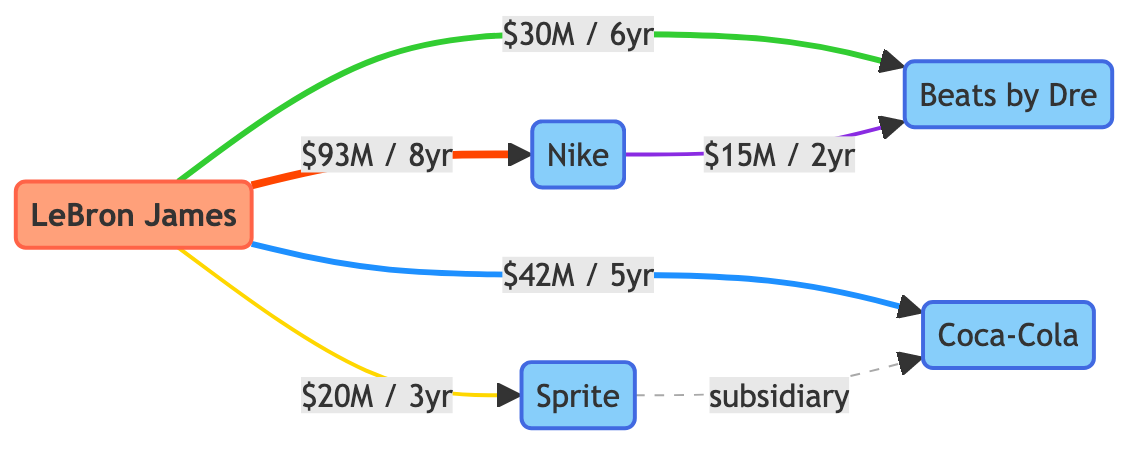What is the duration of LeBron James' endorsement deal with Nike? The diagram highlights the endorsement link between LeBron James and Nike, which specifies a duration of 8 years.
Answer: 8 years What is the deal value for LeBron James' partnership with Coca-Cola? The diagram shows a direct endorsement connection between LeBron James and Coca-Cola with a deal value of 42 million USD.
Answer: 42 million USD How many brands are connected to LeBron James in the diagram? By reviewing the connections from LeBron James, we see he has endorsements with four different brands: Nike, Coca-Cola, Beats, and Sprite, totaling four brands.
Answer: 4 What type of relationship exists between Sprite and Coca-Cola? The diagram illustrates a dashed relationship labeled as "subsidiary" between Sprite and Coca-Cola, indicating a specific business relationship.
Answer: subsidiary What is the total deal value of the endorsement contracts that LeBron James has? To find the total, I add the individual deal values: 93 million (Nike) + 42 million (Coca-Cola) + 30 million (Beats) + 20 million (Sprite), resulting in a total of 185 million USD.
Answer: 185 million USD Which brand has the largest market capitalization? The diagram presents market capitalizations for all brands: Nike (241 billion USD), Coca-Cola (252 billion USD), Beats (3 billion USD), and Sprite (130 billion USD). Coca-Cola has the highest value.
Answer: Coca-Cola How long is the partnership duration between Nike and Beats? The diagram indicates that the partnership between Nike and Beats lasts for 2 years.
Answer: 2 years Which endorsement has the shortest duration? Analyzing the endorsement durations, the shortest one is with Sprite at 3 years, making it the least lengthy deal in comparison to the others.
Answer: 3 years What connection type is described between Nike and Beats? The diagram clearly indicates a partnership relationship between Nike and Beats, marked as such in the connections.
Answer: partnership 